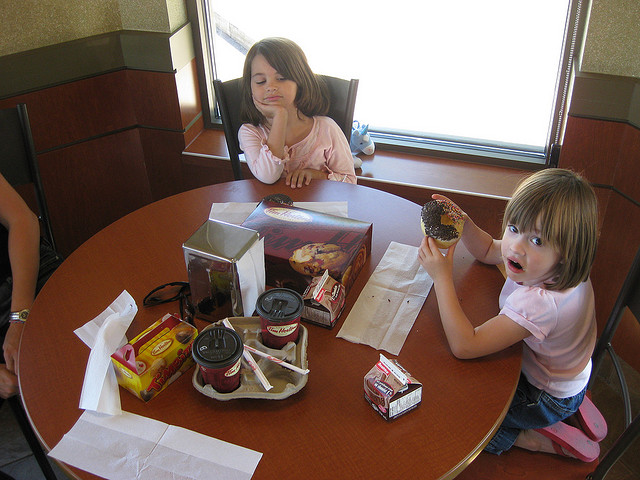<image>What is in the small yellow box? I am not sure about what is in the small yellow box. It could be donuts, snack, tea, money, animal crackers or food. What is in the small yellow box? I don't know what is in the small yellow box. It can be donuts, snack, donut holes, tea, money, animal crackers, tea, butter, or food. 